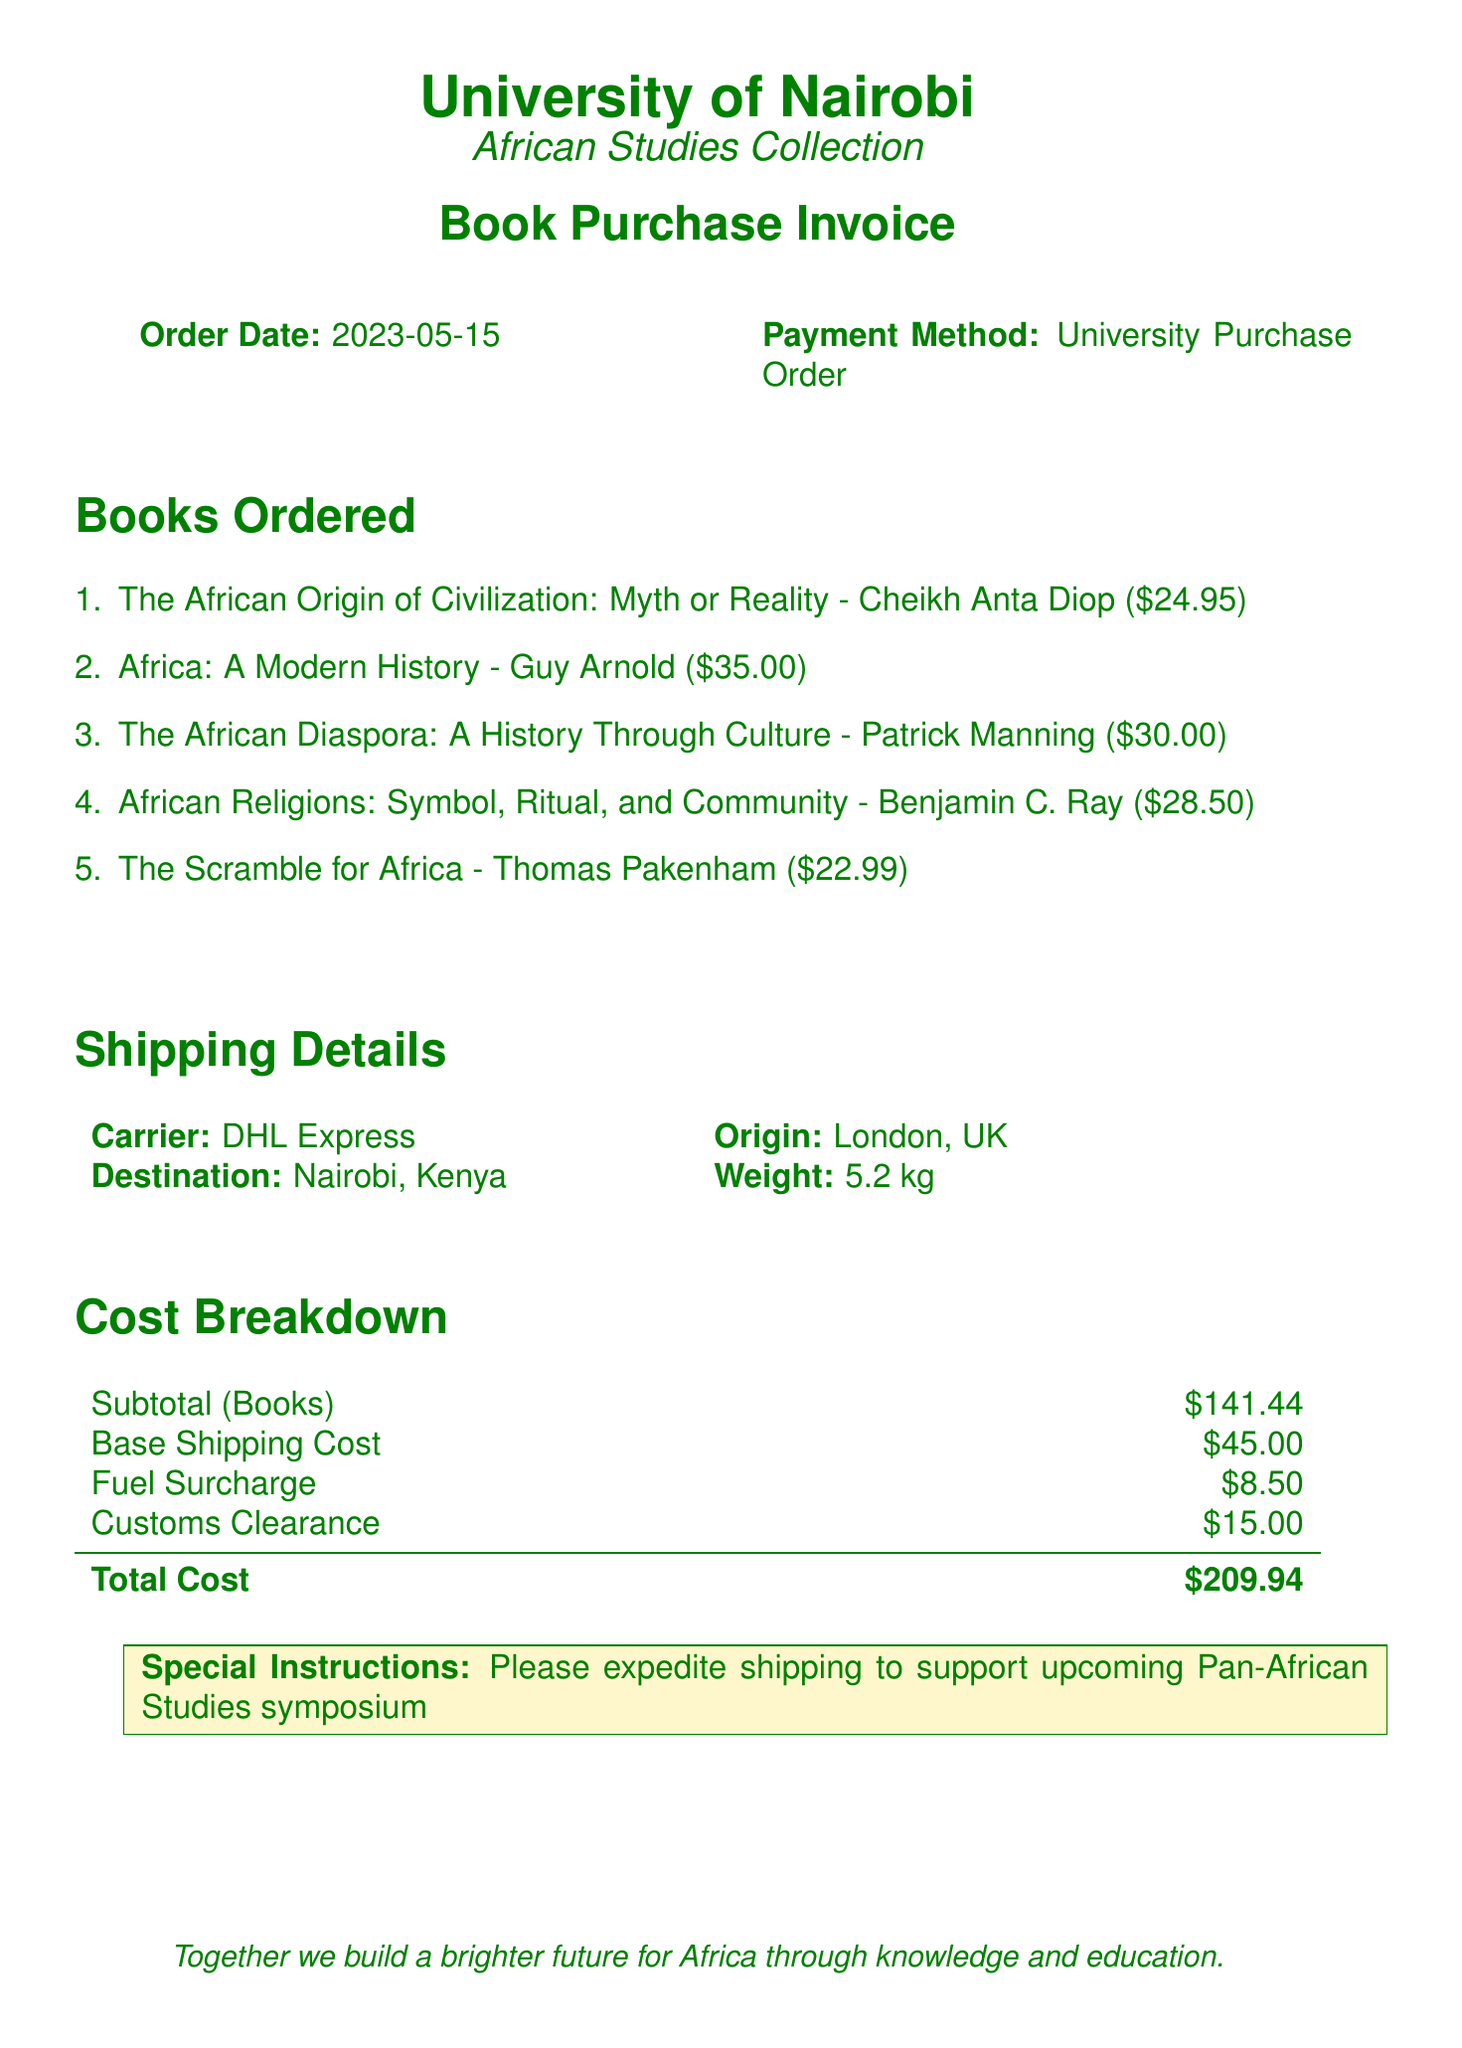What is the order date? The order date is specified in the document as May 15, 2023.
Answer: 2023-05-15 What is the payment method? The payment method listed in the document is the University Purchase Order.
Answer: University Purchase Order Who is the author of "The African Origin of Civilization: Myth or Reality"? The author of the book is Cheikh Anta Diop, as mentioned in the itemized list.
Answer: Cheikh Anta Diop What is the subtotal for the books? The subtotal for the books is provided in the cost breakdown section of the document.
Answer: $141.44 What is the total cost? The total cost is calculated by summing the subtotal and all additional fees stated in the document.
Answer: $209.94 What is the carrier used for shipping? The document specifically lists the carrier as DHL Express.
Answer: DHL Express How much is the customs clearance fee? The customs clearance fee is included in the cost breakdown section of the document.
Answer: $15.00 What is the weight of the shipment? The weight of the shipment is stated in the shipping details.
Answer: 5.2 kg What is the special instruction noted in the document? The special instruction requests expedited shipping for a symposium.
Answer: Please expedite shipping to support upcoming Pan-African Studies symposium 